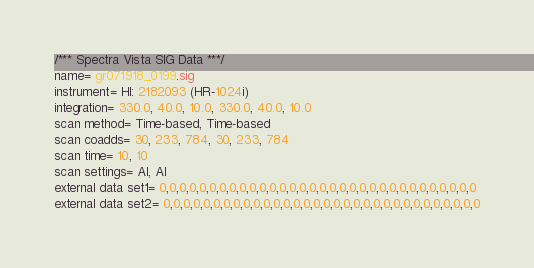<code> <loc_0><loc_0><loc_500><loc_500><_SML_>/*** Spectra Vista SIG Data ***/
name= gr071918_0199.sig
instrument= HI: 2182093 (HR-1024i)
integration= 330.0, 40.0, 10.0, 330.0, 40.0, 10.0
scan method= Time-based, Time-based
scan coadds= 30, 233, 784, 30, 233, 784
scan time= 10, 10
scan settings= AI, AI
external data set1= 0,0,0,0,0,0,0,0,0,0,0,0,0,0,0,0,0,0,0,0,0,0,0,0,0,0,0,0,0,0,0,0
external data set2= 0,0,0,0,0,0,0,0,0,0,0,0,0,0,0,0,0,0,0,0,0,0,0,0,0,0,0,0,0,0,0,0</code> 